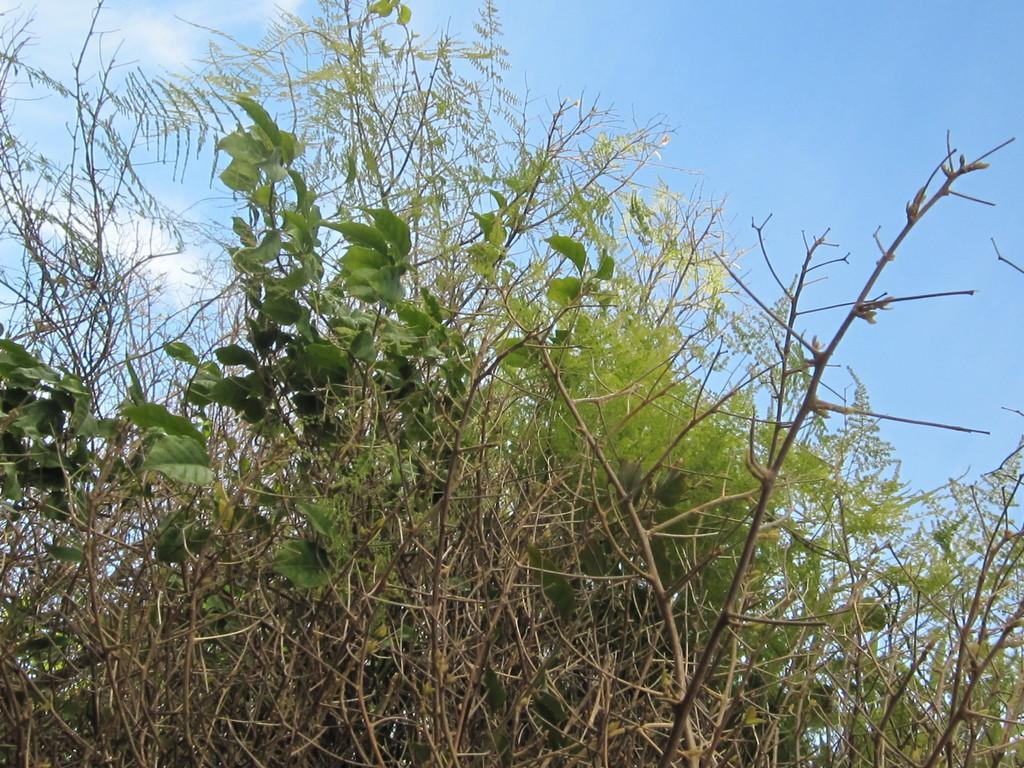In one or two sentences, can you explain what this image depicts? In the image there are plants and trees in the front and above its sky with clouds. 